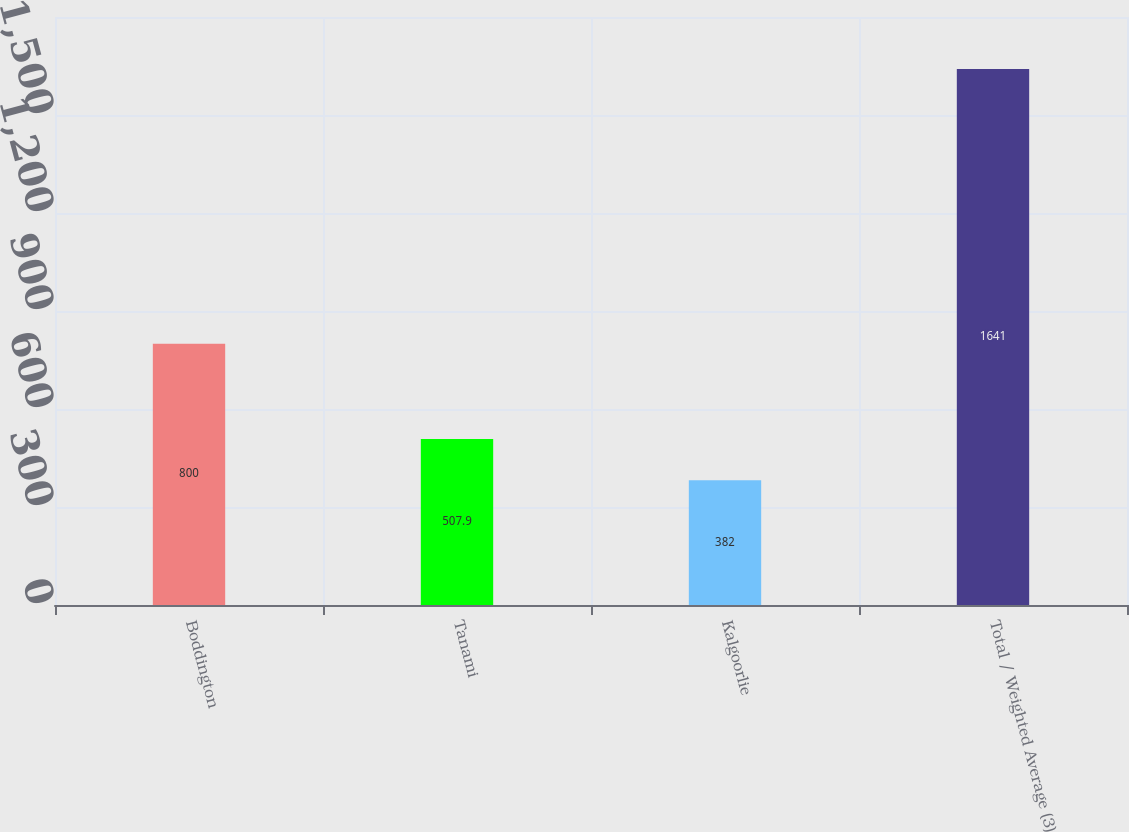<chart> <loc_0><loc_0><loc_500><loc_500><bar_chart><fcel>Boddington<fcel>Tanami<fcel>Kalgoorlie<fcel>Total / Weighted Average (3)<nl><fcel>800<fcel>507.9<fcel>382<fcel>1641<nl></chart> 